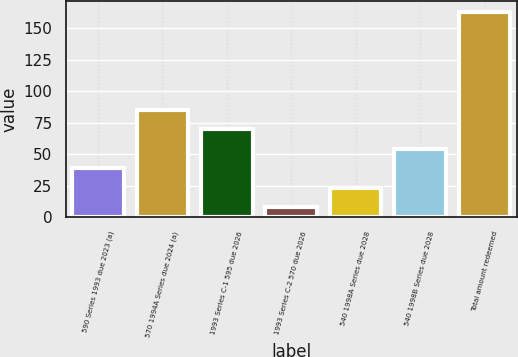Convert chart. <chart><loc_0><loc_0><loc_500><loc_500><bar_chart><fcel>590 Series 1993 due 2023 (a)<fcel>570 1994A Series due 2024 (a)<fcel>1993 Series C-1 595 due 2026<fcel>1993 Series C-2 570 due 2026<fcel>540 1998A Series due 2028<fcel>540 1998B Series due 2028<fcel>Total amount redeemed<nl><fcel>39<fcel>85.5<fcel>70<fcel>8<fcel>23.5<fcel>54.5<fcel>163<nl></chart> 